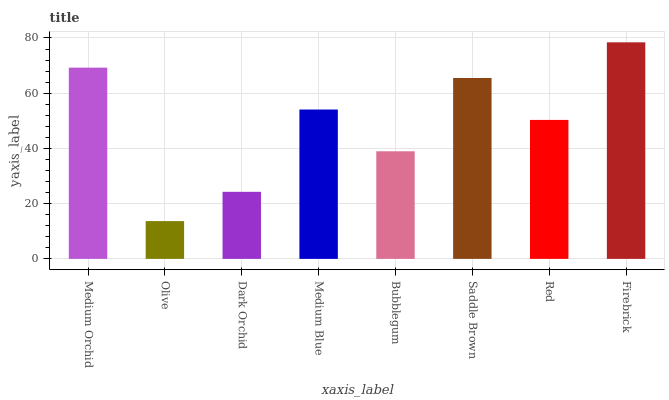Is Olive the minimum?
Answer yes or no. Yes. Is Firebrick the maximum?
Answer yes or no. Yes. Is Dark Orchid the minimum?
Answer yes or no. No. Is Dark Orchid the maximum?
Answer yes or no. No. Is Dark Orchid greater than Olive?
Answer yes or no. Yes. Is Olive less than Dark Orchid?
Answer yes or no. Yes. Is Olive greater than Dark Orchid?
Answer yes or no. No. Is Dark Orchid less than Olive?
Answer yes or no. No. Is Medium Blue the high median?
Answer yes or no. Yes. Is Red the low median?
Answer yes or no. Yes. Is Medium Orchid the high median?
Answer yes or no. No. Is Firebrick the low median?
Answer yes or no. No. 